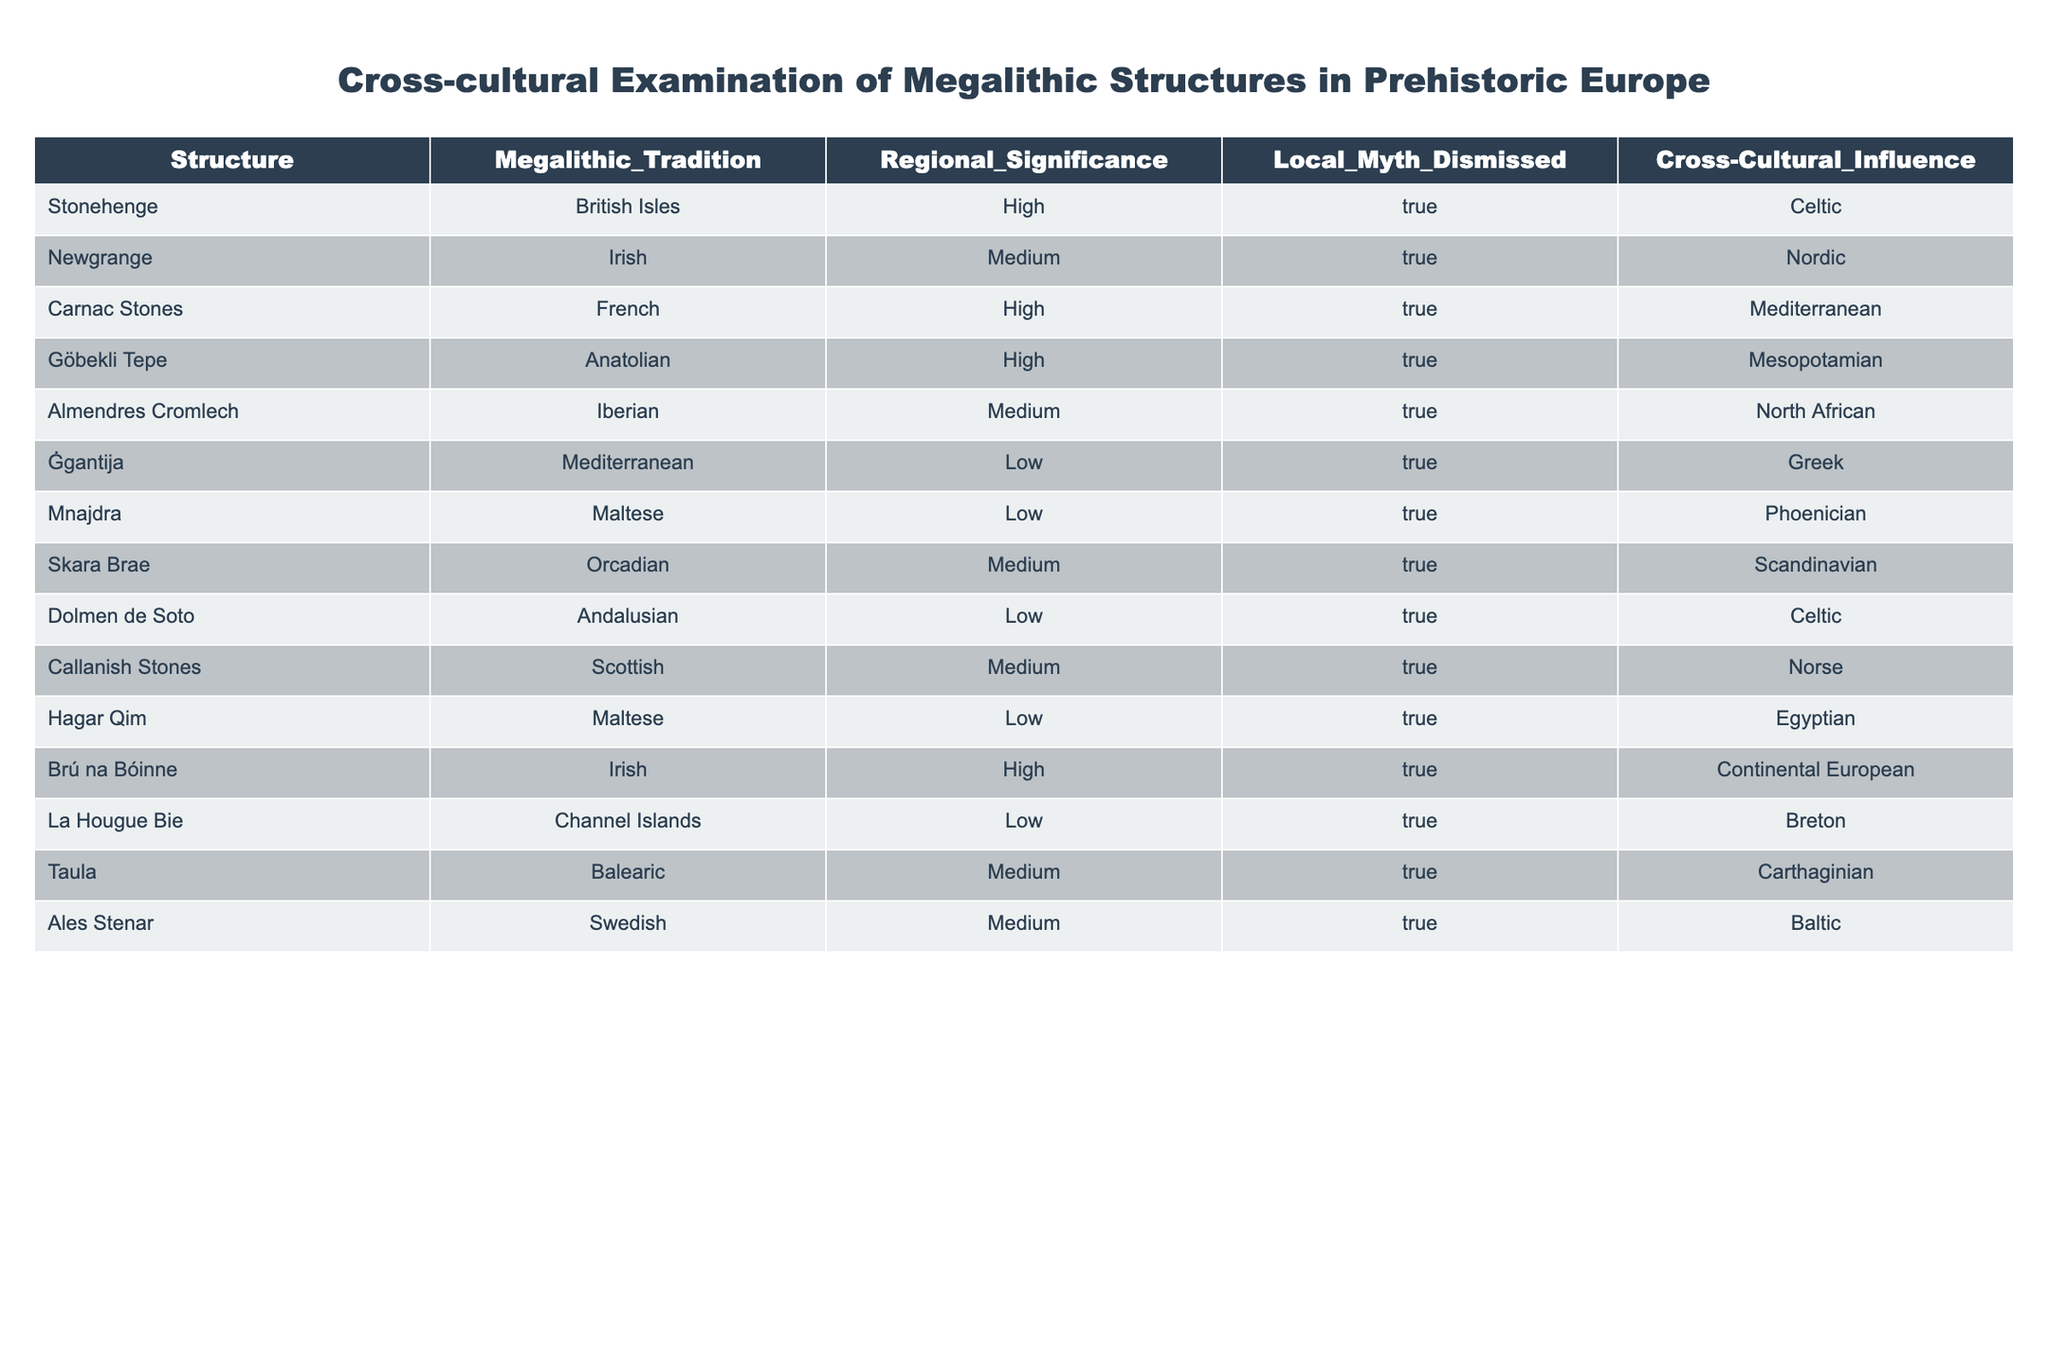What is the megalithic tradition of Stonehenge? The table directly lists Stonehenge under the "Megalithic Tradition" column, showing that it belongs to the "British Isles" tradition.
Answer: British Isles How many structures have a high regional significance? By counting the "High" entries in the "Regional Significance" column, we find that there are 5 structures (Stonehenge, Carnac Stones, Göbekli Tepe, Brú na Bóinne, and Callanish Stones) with a high regional significance.
Answer: 5 Is the local myth dismissed for the Newgrange structure? Looking at the "Local Myth Dismissed" column, it indicates "True" for Newgrange, confirming that the local myth is indeed dismissed.
Answer: Yes What is the cross-cultural influence of Ġgantija? The "Cross-Cultural Influence" column for Ġgantija shows "Greek," reflecting its cultural connections.
Answer: Greek Which megalithic structure has the Mediterranean as its cross-cultural influence and a low regional significance? By checking the "Regional Significance" column for structures with "Low" and then reviewing the "Cross-Cultural Influence" column, we find that Ġgantija has a Mediterranean influence.
Answer: Ġgantija How many structures have Celtic as their cross-cultural influence? We scan the "Cross-Cultural Influence" column for "Celtic," and count the occurrences, which shows there are 3 structures (Stonehenge, Dolmen de Soto, and Callanish Stones) associated with Celtic influence.
Answer: 3 What is the average regional significance across all structures? The values for regional significance can be categorized as High = 3, Medium = 2, and Low = 1. Counting the structures: there are 5 High, 6 Medium, and 6 Low gives us a total score of (5*3 + 6*2 + 6*1) = 15 + 12 + 6 = 33. The average is then 33/17 = approximately 1.94, which indicates the average falls between Medium and Low.
Answer: Approximately 1.94 Are all structures from the table located exclusively in Europe? Yes, all listed structures are from various regions in Europe which is confirmed by the "Megalithic Tradition" column showing European locations.
Answer: Yes What is the significance of comparing the almendres Cromlech and the Skara Brae in terms of cross-cultural influence? Both share medium regional significance, but they differ in their cultural connections; Almendres Cromlech has North African influence, while Skara Brae connects to Scandinavian culture, highlighting diverse influences despite similar significance.
Answer: Different cross-cultural influences 